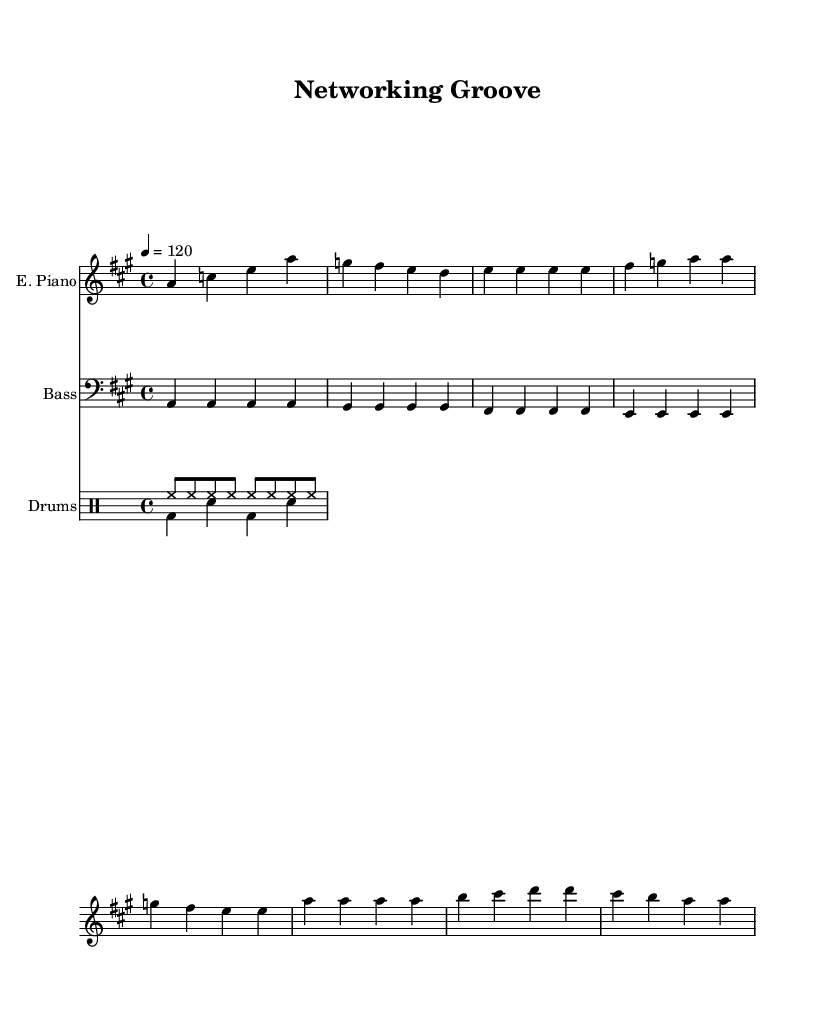What is the key signature of this music? The key signature is A major, which has three sharps (F#, C#, and G#).
Answer: A major What is the time signature of this music? The time signature is 4/4, indicating four beats per measure with a quarter note receiving one beat.
Answer: 4/4 What is the tempo marking for this piece? The tempo marking is "4 = 120", which specifies that there are 120 beats per minute.
Answer: 120 How many measures are present in the verse section? The verse section consists of 4 measures as indicated by the sequence of notes.
Answer: 4 What type of instrument plays the bass line? The bass line is played by a bass guitar, as indicated by the staff label in the music.
Answer: Bass What is the overall theme of the lyrics in this music? The overall theme is networking and professional relationships in the real estate industry, as reflected in the lyrics.
Answer: Networking What rhythmic pattern does the drum section follow? The drum section follows a typical disco rhythmic pattern with a hi-hat playing a steady eighth note pattern and bass drum accents.
Answer: Disco rhythm 